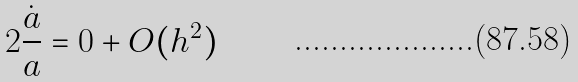Convert formula to latex. <formula><loc_0><loc_0><loc_500><loc_500>2 \frac { \dot { a } } { a } = 0 + O ( h ^ { 2 } )</formula> 